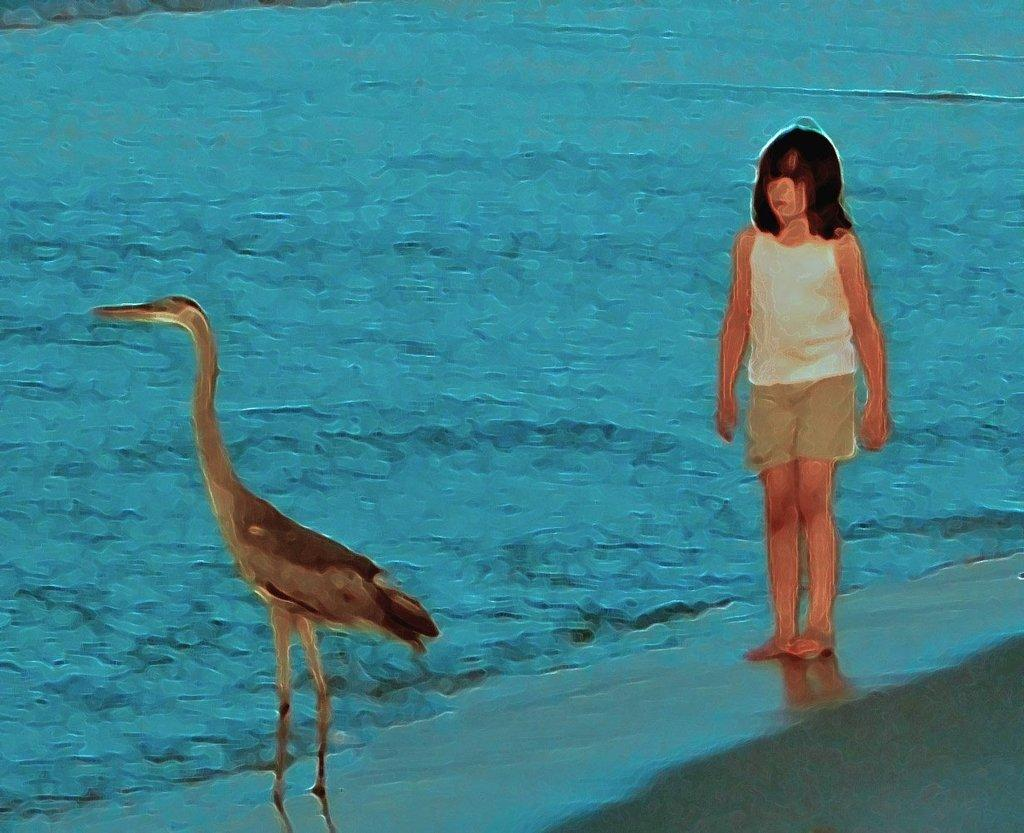What type of artwork is depicted in the image? The image appears to be a painting. What can be seen in the painting besides the artwork itself? There is an animal and a girl standing in the image. What is the level of the cow's water tank in the image? There is no cow or water tank present in the image. 